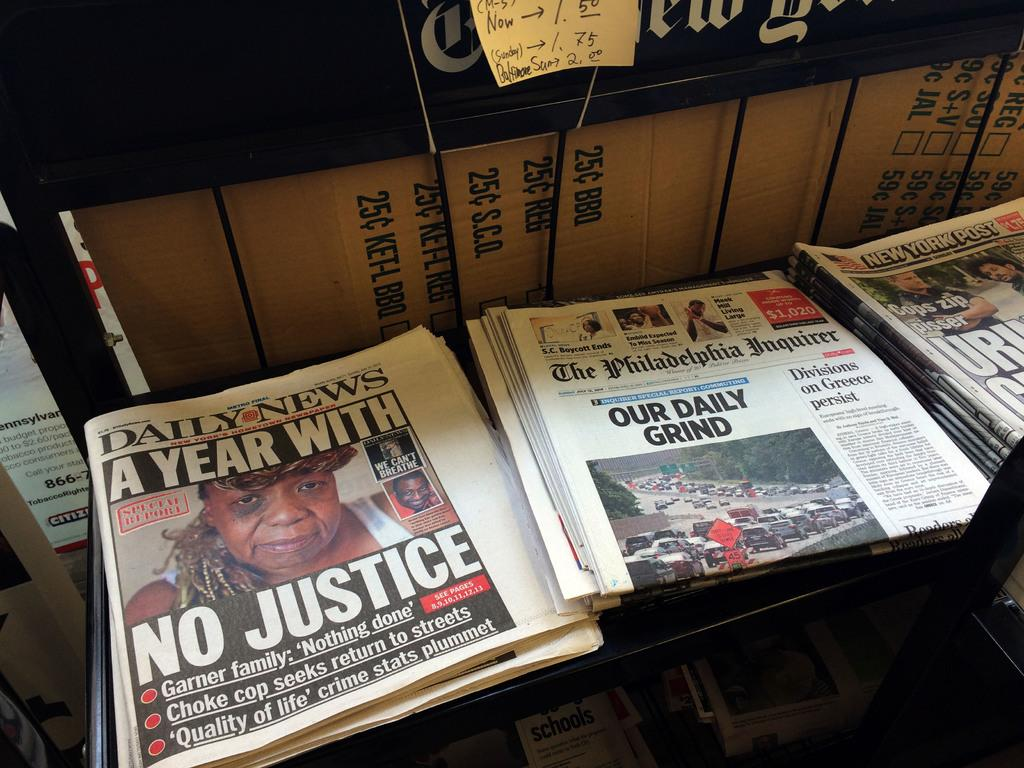Provide a one-sentence caption for the provided image. Our Daily Grind newspaper in between some other newspapers. 